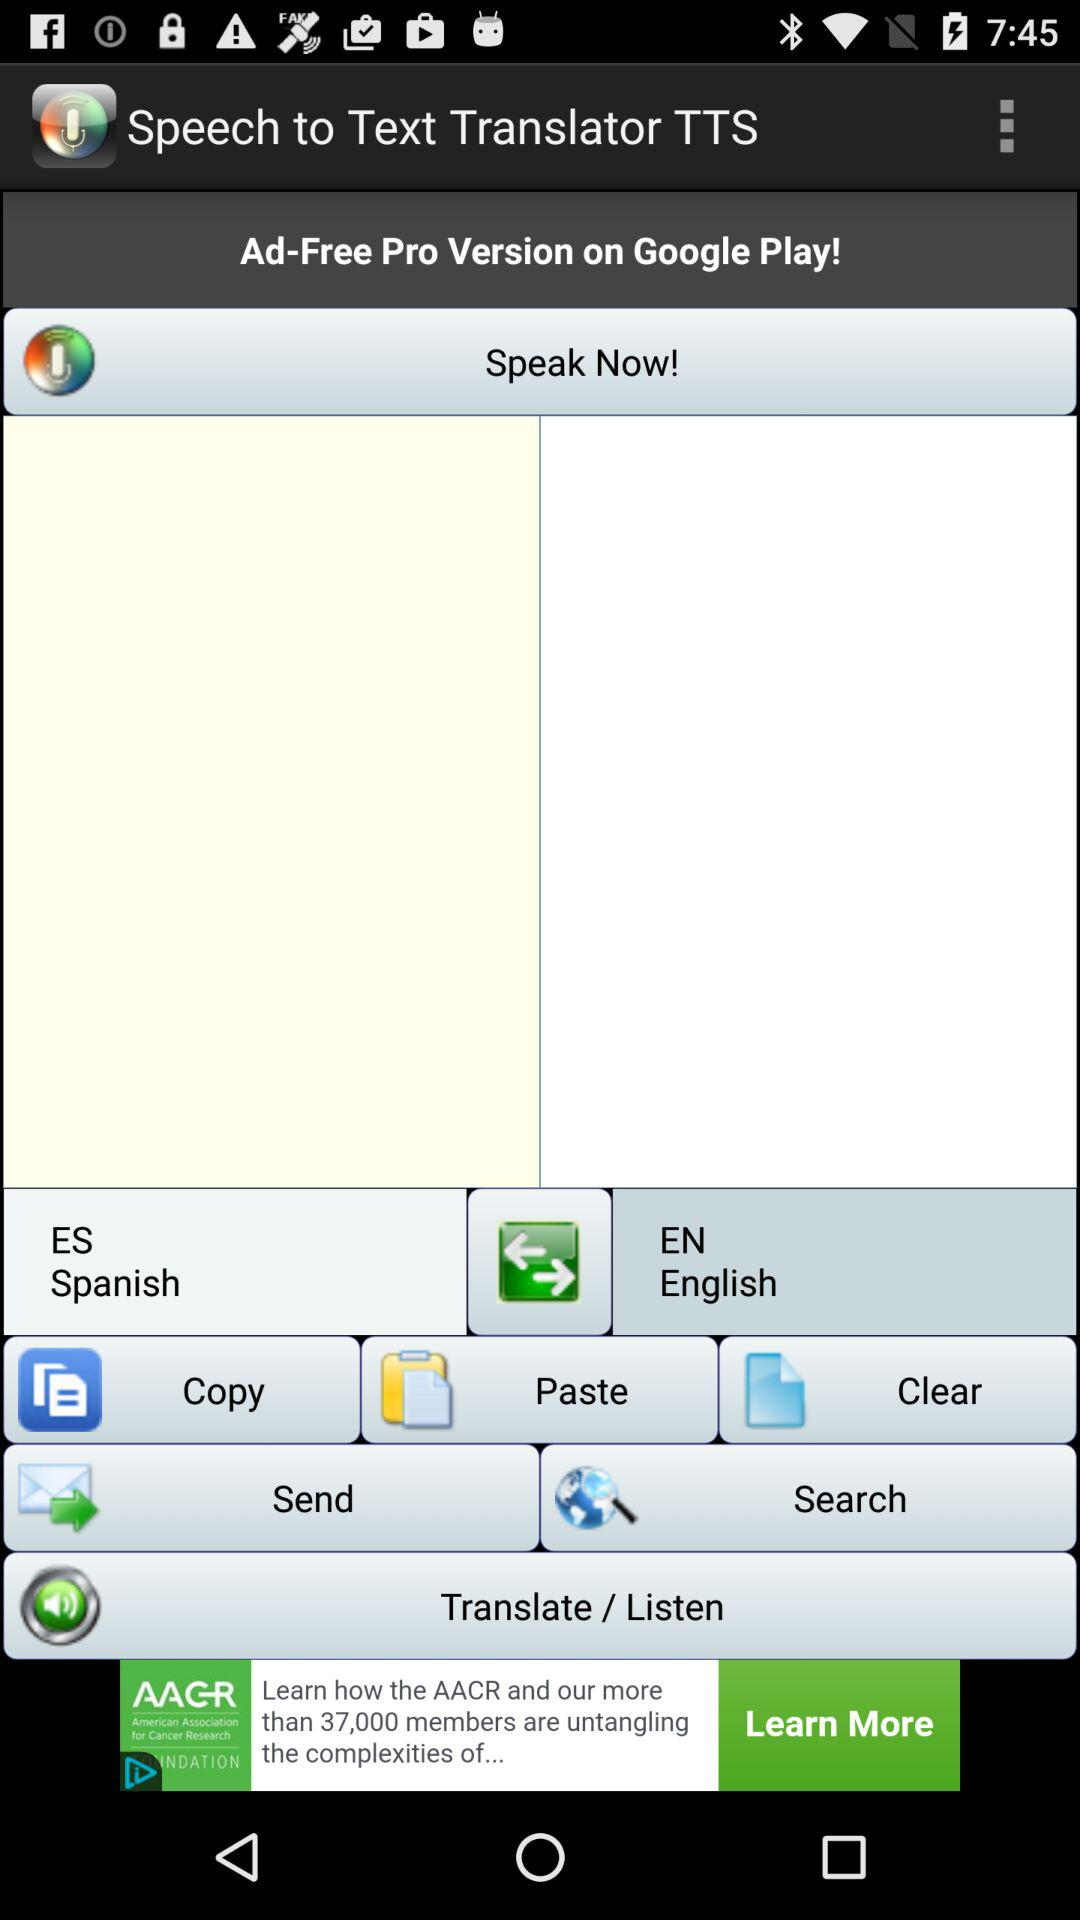How many languages are available in the language selection bar?
Answer the question using a single word or phrase. 2 